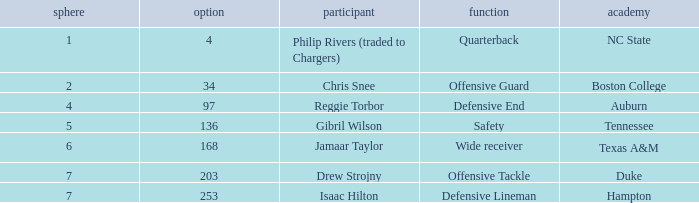What position does a player like gibril wilson hold? Safety. 